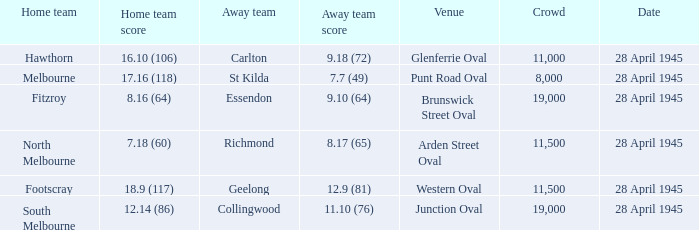What home team has an Away team of richmond? North Melbourne. 